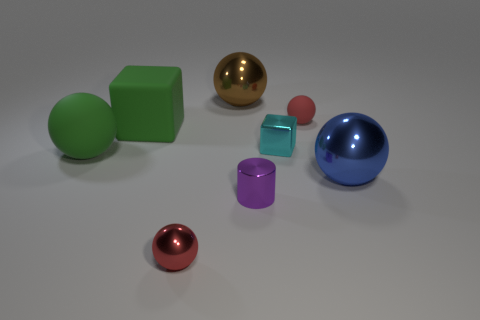Subtract all green balls. How many balls are left? 4 Subtract all small red matte balls. How many balls are left? 4 Subtract all purple balls. Subtract all red cylinders. How many balls are left? 5 Add 1 tiny yellow matte balls. How many objects exist? 9 Subtract all cubes. How many objects are left? 6 Subtract all large gray metal things. Subtract all large balls. How many objects are left? 5 Add 7 big metallic balls. How many big metallic balls are left? 9 Add 5 tiny cyan metallic objects. How many tiny cyan metallic objects exist? 6 Subtract 0 cyan cylinders. How many objects are left? 8 